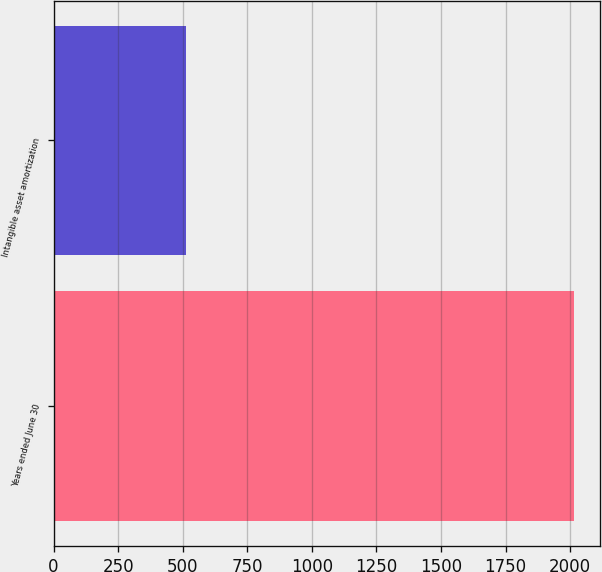<chart> <loc_0><loc_0><loc_500><loc_500><bar_chart><fcel>Years ended June 30<fcel>Intangible asset amortization<nl><fcel>2014<fcel>514<nl></chart> 